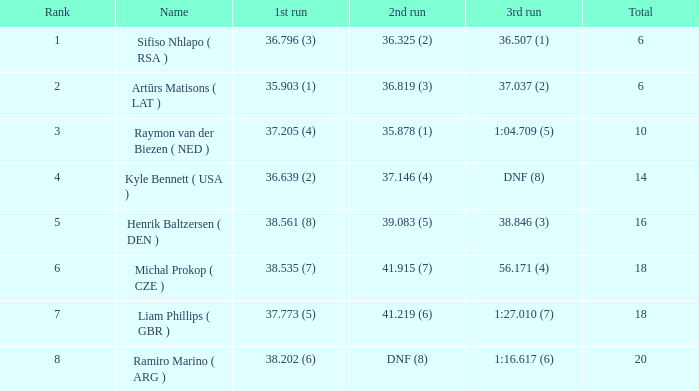Which third attempt holds a ranking of 8? 1:16.617 (6). 